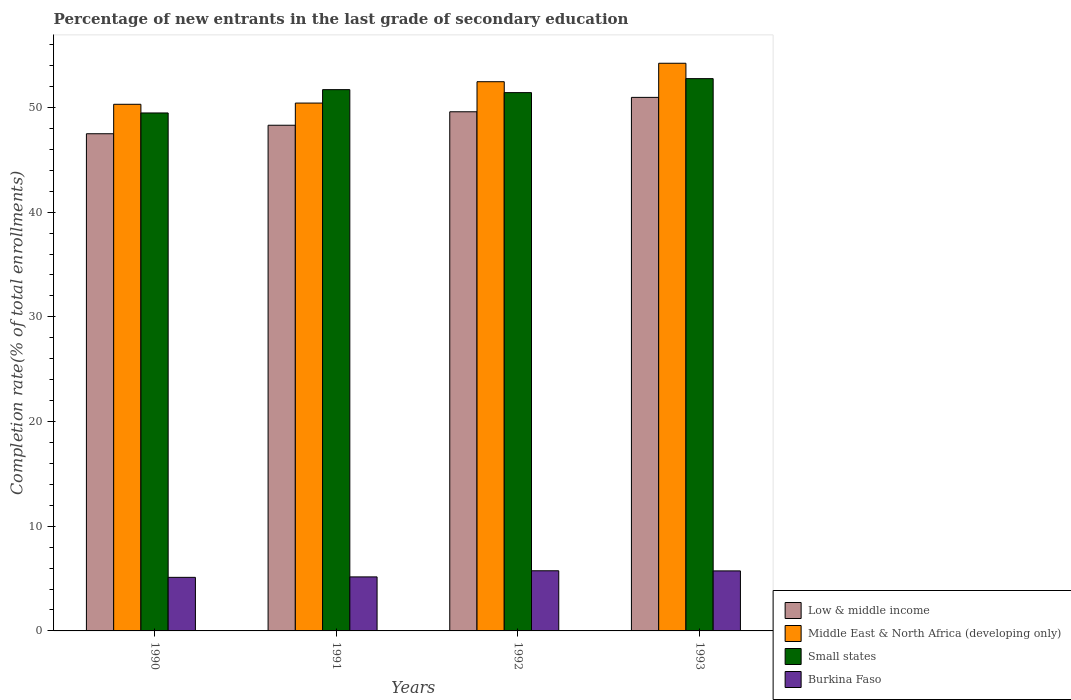How many bars are there on the 2nd tick from the left?
Your answer should be very brief. 4. How many bars are there on the 2nd tick from the right?
Your answer should be very brief. 4. In how many cases, is the number of bars for a given year not equal to the number of legend labels?
Ensure brevity in your answer.  0. What is the percentage of new entrants in Burkina Faso in 1991?
Keep it short and to the point. 5.16. Across all years, what is the maximum percentage of new entrants in Middle East & North Africa (developing only)?
Your response must be concise. 54.22. Across all years, what is the minimum percentage of new entrants in Low & middle income?
Make the answer very short. 47.49. In which year was the percentage of new entrants in Low & middle income maximum?
Offer a very short reply. 1993. In which year was the percentage of new entrants in Small states minimum?
Provide a short and direct response. 1990. What is the total percentage of new entrants in Low & middle income in the graph?
Give a very brief answer. 196.35. What is the difference between the percentage of new entrants in Low & middle income in 1991 and that in 1992?
Your answer should be very brief. -1.29. What is the difference between the percentage of new entrants in Small states in 1991 and the percentage of new entrants in Burkina Faso in 1990?
Offer a very short reply. 46.59. What is the average percentage of new entrants in Middle East & North Africa (developing only) per year?
Your response must be concise. 51.85. In the year 1991, what is the difference between the percentage of new entrants in Low & middle income and percentage of new entrants in Small states?
Your answer should be very brief. -3.4. In how many years, is the percentage of new entrants in Burkina Faso greater than 6 %?
Provide a succinct answer. 0. What is the ratio of the percentage of new entrants in Low & middle income in 1992 to that in 1993?
Give a very brief answer. 0.97. Is the percentage of new entrants in Burkina Faso in 1991 less than that in 1993?
Your answer should be compact. Yes. Is the difference between the percentage of new entrants in Low & middle income in 1990 and 1991 greater than the difference between the percentage of new entrants in Small states in 1990 and 1991?
Make the answer very short. Yes. What is the difference between the highest and the second highest percentage of new entrants in Burkina Faso?
Your answer should be compact. 0.01. What is the difference between the highest and the lowest percentage of new entrants in Small states?
Keep it short and to the point. 3.28. Is the sum of the percentage of new entrants in Small states in 1992 and 1993 greater than the maximum percentage of new entrants in Burkina Faso across all years?
Provide a succinct answer. Yes. Is it the case that in every year, the sum of the percentage of new entrants in Middle East & North Africa (developing only) and percentage of new entrants in Small states is greater than the sum of percentage of new entrants in Burkina Faso and percentage of new entrants in Low & middle income?
Offer a terse response. No. What does the 4th bar from the left in 1992 represents?
Offer a terse response. Burkina Faso. What does the 4th bar from the right in 1993 represents?
Give a very brief answer. Low & middle income. How many legend labels are there?
Offer a very short reply. 4. How are the legend labels stacked?
Provide a short and direct response. Vertical. What is the title of the graph?
Offer a very short reply. Percentage of new entrants in the last grade of secondary education. Does "Belize" appear as one of the legend labels in the graph?
Give a very brief answer. No. What is the label or title of the Y-axis?
Your response must be concise. Completion rate(% of total enrollments). What is the Completion rate(% of total enrollments) of Low & middle income in 1990?
Your answer should be very brief. 47.49. What is the Completion rate(% of total enrollments) in Middle East & North Africa (developing only) in 1990?
Your answer should be very brief. 50.3. What is the Completion rate(% of total enrollments) in Small states in 1990?
Your answer should be very brief. 49.48. What is the Completion rate(% of total enrollments) in Burkina Faso in 1990?
Make the answer very short. 5.12. What is the Completion rate(% of total enrollments) in Low & middle income in 1991?
Offer a very short reply. 48.3. What is the Completion rate(% of total enrollments) of Middle East & North Africa (developing only) in 1991?
Your answer should be compact. 50.42. What is the Completion rate(% of total enrollments) in Small states in 1991?
Your response must be concise. 51.7. What is the Completion rate(% of total enrollments) of Burkina Faso in 1991?
Your answer should be very brief. 5.16. What is the Completion rate(% of total enrollments) in Low & middle income in 1992?
Your answer should be compact. 49.59. What is the Completion rate(% of total enrollments) in Middle East & North Africa (developing only) in 1992?
Offer a very short reply. 52.46. What is the Completion rate(% of total enrollments) of Small states in 1992?
Provide a short and direct response. 51.42. What is the Completion rate(% of total enrollments) in Burkina Faso in 1992?
Provide a short and direct response. 5.75. What is the Completion rate(% of total enrollments) in Low & middle income in 1993?
Your answer should be very brief. 50.96. What is the Completion rate(% of total enrollments) in Middle East & North Africa (developing only) in 1993?
Ensure brevity in your answer.  54.22. What is the Completion rate(% of total enrollments) of Small states in 1993?
Provide a succinct answer. 52.75. What is the Completion rate(% of total enrollments) of Burkina Faso in 1993?
Ensure brevity in your answer.  5.73. Across all years, what is the maximum Completion rate(% of total enrollments) of Low & middle income?
Your answer should be compact. 50.96. Across all years, what is the maximum Completion rate(% of total enrollments) of Middle East & North Africa (developing only)?
Your answer should be very brief. 54.22. Across all years, what is the maximum Completion rate(% of total enrollments) of Small states?
Your answer should be compact. 52.75. Across all years, what is the maximum Completion rate(% of total enrollments) in Burkina Faso?
Offer a very short reply. 5.75. Across all years, what is the minimum Completion rate(% of total enrollments) in Low & middle income?
Offer a very short reply. 47.49. Across all years, what is the minimum Completion rate(% of total enrollments) of Middle East & North Africa (developing only)?
Offer a terse response. 50.3. Across all years, what is the minimum Completion rate(% of total enrollments) in Small states?
Your answer should be very brief. 49.48. Across all years, what is the minimum Completion rate(% of total enrollments) in Burkina Faso?
Your answer should be compact. 5.12. What is the total Completion rate(% of total enrollments) of Low & middle income in the graph?
Provide a succinct answer. 196.35. What is the total Completion rate(% of total enrollments) of Middle East & North Africa (developing only) in the graph?
Make the answer very short. 207.41. What is the total Completion rate(% of total enrollments) in Small states in the graph?
Offer a terse response. 205.35. What is the total Completion rate(% of total enrollments) in Burkina Faso in the graph?
Your response must be concise. 21.76. What is the difference between the Completion rate(% of total enrollments) of Low & middle income in 1990 and that in 1991?
Provide a succinct answer. -0.81. What is the difference between the Completion rate(% of total enrollments) in Middle East & North Africa (developing only) in 1990 and that in 1991?
Keep it short and to the point. -0.12. What is the difference between the Completion rate(% of total enrollments) in Small states in 1990 and that in 1991?
Offer a terse response. -2.23. What is the difference between the Completion rate(% of total enrollments) in Burkina Faso in 1990 and that in 1991?
Your response must be concise. -0.04. What is the difference between the Completion rate(% of total enrollments) in Low & middle income in 1990 and that in 1992?
Offer a terse response. -2.1. What is the difference between the Completion rate(% of total enrollments) of Middle East & North Africa (developing only) in 1990 and that in 1992?
Keep it short and to the point. -2.16. What is the difference between the Completion rate(% of total enrollments) in Small states in 1990 and that in 1992?
Offer a very short reply. -1.94. What is the difference between the Completion rate(% of total enrollments) of Burkina Faso in 1990 and that in 1992?
Ensure brevity in your answer.  -0.63. What is the difference between the Completion rate(% of total enrollments) of Low & middle income in 1990 and that in 1993?
Provide a short and direct response. -3.47. What is the difference between the Completion rate(% of total enrollments) of Middle East & North Africa (developing only) in 1990 and that in 1993?
Keep it short and to the point. -3.92. What is the difference between the Completion rate(% of total enrollments) of Small states in 1990 and that in 1993?
Offer a terse response. -3.28. What is the difference between the Completion rate(% of total enrollments) of Burkina Faso in 1990 and that in 1993?
Offer a terse response. -0.62. What is the difference between the Completion rate(% of total enrollments) in Low & middle income in 1991 and that in 1992?
Your answer should be compact. -1.29. What is the difference between the Completion rate(% of total enrollments) of Middle East & North Africa (developing only) in 1991 and that in 1992?
Your answer should be very brief. -2.04. What is the difference between the Completion rate(% of total enrollments) in Small states in 1991 and that in 1992?
Provide a short and direct response. 0.28. What is the difference between the Completion rate(% of total enrollments) of Burkina Faso in 1991 and that in 1992?
Your answer should be very brief. -0.59. What is the difference between the Completion rate(% of total enrollments) in Low & middle income in 1991 and that in 1993?
Ensure brevity in your answer.  -2.66. What is the difference between the Completion rate(% of total enrollments) of Middle East & North Africa (developing only) in 1991 and that in 1993?
Provide a succinct answer. -3.8. What is the difference between the Completion rate(% of total enrollments) of Small states in 1991 and that in 1993?
Your response must be concise. -1.05. What is the difference between the Completion rate(% of total enrollments) of Burkina Faso in 1991 and that in 1993?
Offer a very short reply. -0.57. What is the difference between the Completion rate(% of total enrollments) of Low & middle income in 1992 and that in 1993?
Your answer should be very brief. -1.37. What is the difference between the Completion rate(% of total enrollments) of Middle East & North Africa (developing only) in 1992 and that in 1993?
Your answer should be compact. -1.76. What is the difference between the Completion rate(% of total enrollments) of Small states in 1992 and that in 1993?
Give a very brief answer. -1.34. What is the difference between the Completion rate(% of total enrollments) in Burkina Faso in 1992 and that in 1993?
Offer a very short reply. 0.01. What is the difference between the Completion rate(% of total enrollments) of Low & middle income in 1990 and the Completion rate(% of total enrollments) of Middle East & North Africa (developing only) in 1991?
Your answer should be compact. -2.93. What is the difference between the Completion rate(% of total enrollments) in Low & middle income in 1990 and the Completion rate(% of total enrollments) in Small states in 1991?
Offer a terse response. -4.21. What is the difference between the Completion rate(% of total enrollments) of Low & middle income in 1990 and the Completion rate(% of total enrollments) of Burkina Faso in 1991?
Provide a succinct answer. 42.33. What is the difference between the Completion rate(% of total enrollments) in Middle East & North Africa (developing only) in 1990 and the Completion rate(% of total enrollments) in Small states in 1991?
Provide a short and direct response. -1.4. What is the difference between the Completion rate(% of total enrollments) in Middle East & North Africa (developing only) in 1990 and the Completion rate(% of total enrollments) in Burkina Faso in 1991?
Provide a short and direct response. 45.14. What is the difference between the Completion rate(% of total enrollments) in Small states in 1990 and the Completion rate(% of total enrollments) in Burkina Faso in 1991?
Keep it short and to the point. 44.32. What is the difference between the Completion rate(% of total enrollments) in Low & middle income in 1990 and the Completion rate(% of total enrollments) in Middle East & North Africa (developing only) in 1992?
Provide a succinct answer. -4.97. What is the difference between the Completion rate(% of total enrollments) of Low & middle income in 1990 and the Completion rate(% of total enrollments) of Small states in 1992?
Your response must be concise. -3.93. What is the difference between the Completion rate(% of total enrollments) in Low & middle income in 1990 and the Completion rate(% of total enrollments) in Burkina Faso in 1992?
Your answer should be compact. 41.75. What is the difference between the Completion rate(% of total enrollments) of Middle East & North Africa (developing only) in 1990 and the Completion rate(% of total enrollments) of Small states in 1992?
Ensure brevity in your answer.  -1.11. What is the difference between the Completion rate(% of total enrollments) in Middle East & North Africa (developing only) in 1990 and the Completion rate(% of total enrollments) in Burkina Faso in 1992?
Your answer should be very brief. 44.56. What is the difference between the Completion rate(% of total enrollments) in Small states in 1990 and the Completion rate(% of total enrollments) in Burkina Faso in 1992?
Keep it short and to the point. 43.73. What is the difference between the Completion rate(% of total enrollments) in Low & middle income in 1990 and the Completion rate(% of total enrollments) in Middle East & North Africa (developing only) in 1993?
Make the answer very short. -6.73. What is the difference between the Completion rate(% of total enrollments) of Low & middle income in 1990 and the Completion rate(% of total enrollments) of Small states in 1993?
Give a very brief answer. -5.26. What is the difference between the Completion rate(% of total enrollments) in Low & middle income in 1990 and the Completion rate(% of total enrollments) in Burkina Faso in 1993?
Provide a succinct answer. 41.76. What is the difference between the Completion rate(% of total enrollments) in Middle East & North Africa (developing only) in 1990 and the Completion rate(% of total enrollments) in Small states in 1993?
Offer a very short reply. -2.45. What is the difference between the Completion rate(% of total enrollments) in Middle East & North Africa (developing only) in 1990 and the Completion rate(% of total enrollments) in Burkina Faso in 1993?
Your response must be concise. 44.57. What is the difference between the Completion rate(% of total enrollments) of Small states in 1990 and the Completion rate(% of total enrollments) of Burkina Faso in 1993?
Offer a terse response. 43.74. What is the difference between the Completion rate(% of total enrollments) in Low & middle income in 1991 and the Completion rate(% of total enrollments) in Middle East & North Africa (developing only) in 1992?
Your answer should be very brief. -4.16. What is the difference between the Completion rate(% of total enrollments) of Low & middle income in 1991 and the Completion rate(% of total enrollments) of Small states in 1992?
Ensure brevity in your answer.  -3.12. What is the difference between the Completion rate(% of total enrollments) in Low & middle income in 1991 and the Completion rate(% of total enrollments) in Burkina Faso in 1992?
Provide a short and direct response. 42.56. What is the difference between the Completion rate(% of total enrollments) in Middle East & North Africa (developing only) in 1991 and the Completion rate(% of total enrollments) in Small states in 1992?
Keep it short and to the point. -1. What is the difference between the Completion rate(% of total enrollments) of Middle East & North Africa (developing only) in 1991 and the Completion rate(% of total enrollments) of Burkina Faso in 1992?
Keep it short and to the point. 44.68. What is the difference between the Completion rate(% of total enrollments) of Small states in 1991 and the Completion rate(% of total enrollments) of Burkina Faso in 1992?
Give a very brief answer. 45.96. What is the difference between the Completion rate(% of total enrollments) of Low & middle income in 1991 and the Completion rate(% of total enrollments) of Middle East & North Africa (developing only) in 1993?
Provide a short and direct response. -5.92. What is the difference between the Completion rate(% of total enrollments) of Low & middle income in 1991 and the Completion rate(% of total enrollments) of Small states in 1993?
Your answer should be very brief. -4.45. What is the difference between the Completion rate(% of total enrollments) in Low & middle income in 1991 and the Completion rate(% of total enrollments) in Burkina Faso in 1993?
Your answer should be very brief. 42.57. What is the difference between the Completion rate(% of total enrollments) of Middle East & North Africa (developing only) in 1991 and the Completion rate(% of total enrollments) of Small states in 1993?
Ensure brevity in your answer.  -2.33. What is the difference between the Completion rate(% of total enrollments) in Middle East & North Africa (developing only) in 1991 and the Completion rate(% of total enrollments) in Burkina Faso in 1993?
Your response must be concise. 44.69. What is the difference between the Completion rate(% of total enrollments) of Small states in 1991 and the Completion rate(% of total enrollments) of Burkina Faso in 1993?
Offer a very short reply. 45.97. What is the difference between the Completion rate(% of total enrollments) in Low & middle income in 1992 and the Completion rate(% of total enrollments) in Middle East & North Africa (developing only) in 1993?
Offer a terse response. -4.63. What is the difference between the Completion rate(% of total enrollments) in Low & middle income in 1992 and the Completion rate(% of total enrollments) in Small states in 1993?
Offer a very short reply. -3.16. What is the difference between the Completion rate(% of total enrollments) in Low & middle income in 1992 and the Completion rate(% of total enrollments) in Burkina Faso in 1993?
Provide a succinct answer. 43.86. What is the difference between the Completion rate(% of total enrollments) of Middle East & North Africa (developing only) in 1992 and the Completion rate(% of total enrollments) of Small states in 1993?
Offer a terse response. -0.29. What is the difference between the Completion rate(% of total enrollments) of Middle East & North Africa (developing only) in 1992 and the Completion rate(% of total enrollments) of Burkina Faso in 1993?
Provide a short and direct response. 46.73. What is the difference between the Completion rate(% of total enrollments) in Small states in 1992 and the Completion rate(% of total enrollments) in Burkina Faso in 1993?
Offer a very short reply. 45.69. What is the average Completion rate(% of total enrollments) in Low & middle income per year?
Make the answer very short. 49.09. What is the average Completion rate(% of total enrollments) of Middle East & North Africa (developing only) per year?
Offer a very short reply. 51.85. What is the average Completion rate(% of total enrollments) in Small states per year?
Ensure brevity in your answer.  51.34. What is the average Completion rate(% of total enrollments) in Burkina Faso per year?
Give a very brief answer. 5.44. In the year 1990, what is the difference between the Completion rate(% of total enrollments) of Low & middle income and Completion rate(% of total enrollments) of Middle East & North Africa (developing only)?
Your answer should be very brief. -2.81. In the year 1990, what is the difference between the Completion rate(% of total enrollments) of Low & middle income and Completion rate(% of total enrollments) of Small states?
Give a very brief answer. -1.99. In the year 1990, what is the difference between the Completion rate(% of total enrollments) of Low & middle income and Completion rate(% of total enrollments) of Burkina Faso?
Keep it short and to the point. 42.37. In the year 1990, what is the difference between the Completion rate(% of total enrollments) in Middle East & North Africa (developing only) and Completion rate(% of total enrollments) in Small states?
Provide a succinct answer. 0.83. In the year 1990, what is the difference between the Completion rate(% of total enrollments) of Middle East & North Africa (developing only) and Completion rate(% of total enrollments) of Burkina Faso?
Your answer should be very brief. 45.19. In the year 1990, what is the difference between the Completion rate(% of total enrollments) in Small states and Completion rate(% of total enrollments) in Burkina Faso?
Ensure brevity in your answer.  44.36. In the year 1991, what is the difference between the Completion rate(% of total enrollments) in Low & middle income and Completion rate(% of total enrollments) in Middle East & North Africa (developing only)?
Offer a very short reply. -2.12. In the year 1991, what is the difference between the Completion rate(% of total enrollments) in Low & middle income and Completion rate(% of total enrollments) in Small states?
Ensure brevity in your answer.  -3.4. In the year 1991, what is the difference between the Completion rate(% of total enrollments) in Low & middle income and Completion rate(% of total enrollments) in Burkina Faso?
Keep it short and to the point. 43.14. In the year 1991, what is the difference between the Completion rate(% of total enrollments) in Middle East & North Africa (developing only) and Completion rate(% of total enrollments) in Small states?
Give a very brief answer. -1.28. In the year 1991, what is the difference between the Completion rate(% of total enrollments) in Middle East & North Africa (developing only) and Completion rate(% of total enrollments) in Burkina Faso?
Ensure brevity in your answer.  45.26. In the year 1991, what is the difference between the Completion rate(% of total enrollments) of Small states and Completion rate(% of total enrollments) of Burkina Faso?
Provide a succinct answer. 46.54. In the year 1992, what is the difference between the Completion rate(% of total enrollments) of Low & middle income and Completion rate(% of total enrollments) of Middle East & North Africa (developing only)?
Your answer should be compact. -2.87. In the year 1992, what is the difference between the Completion rate(% of total enrollments) of Low & middle income and Completion rate(% of total enrollments) of Small states?
Offer a terse response. -1.83. In the year 1992, what is the difference between the Completion rate(% of total enrollments) in Low & middle income and Completion rate(% of total enrollments) in Burkina Faso?
Your answer should be compact. 43.84. In the year 1992, what is the difference between the Completion rate(% of total enrollments) of Middle East & North Africa (developing only) and Completion rate(% of total enrollments) of Small states?
Offer a terse response. 1.04. In the year 1992, what is the difference between the Completion rate(% of total enrollments) of Middle East & North Africa (developing only) and Completion rate(% of total enrollments) of Burkina Faso?
Your answer should be very brief. 46.72. In the year 1992, what is the difference between the Completion rate(% of total enrollments) of Small states and Completion rate(% of total enrollments) of Burkina Faso?
Your answer should be very brief. 45.67. In the year 1993, what is the difference between the Completion rate(% of total enrollments) in Low & middle income and Completion rate(% of total enrollments) in Middle East & North Africa (developing only)?
Your response must be concise. -3.26. In the year 1993, what is the difference between the Completion rate(% of total enrollments) of Low & middle income and Completion rate(% of total enrollments) of Small states?
Your response must be concise. -1.79. In the year 1993, what is the difference between the Completion rate(% of total enrollments) of Low & middle income and Completion rate(% of total enrollments) of Burkina Faso?
Your response must be concise. 45.23. In the year 1993, what is the difference between the Completion rate(% of total enrollments) of Middle East & North Africa (developing only) and Completion rate(% of total enrollments) of Small states?
Provide a succinct answer. 1.47. In the year 1993, what is the difference between the Completion rate(% of total enrollments) of Middle East & North Africa (developing only) and Completion rate(% of total enrollments) of Burkina Faso?
Provide a succinct answer. 48.49. In the year 1993, what is the difference between the Completion rate(% of total enrollments) of Small states and Completion rate(% of total enrollments) of Burkina Faso?
Give a very brief answer. 47.02. What is the ratio of the Completion rate(% of total enrollments) in Low & middle income in 1990 to that in 1991?
Make the answer very short. 0.98. What is the ratio of the Completion rate(% of total enrollments) in Middle East & North Africa (developing only) in 1990 to that in 1991?
Provide a succinct answer. 1. What is the ratio of the Completion rate(% of total enrollments) of Small states in 1990 to that in 1991?
Provide a succinct answer. 0.96. What is the ratio of the Completion rate(% of total enrollments) in Burkina Faso in 1990 to that in 1991?
Offer a very short reply. 0.99. What is the ratio of the Completion rate(% of total enrollments) in Low & middle income in 1990 to that in 1992?
Offer a terse response. 0.96. What is the ratio of the Completion rate(% of total enrollments) in Middle East & North Africa (developing only) in 1990 to that in 1992?
Your answer should be very brief. 0.96. What is the ratio of the Completion rate(% of total enrollments) in Small states in 1990 to that in 1992?
Give a very brief answer. 0.96. What is the ratio of the Completion rate(% of total enrollments) of Burkina Faso in 1990 to that in 1992?
Give a very brief answer. 0.89. What is the ratio of the Completion rate(% of total enrollments) in Low & middle income in 1990 to that in 1993?
Offer a very short reply. 0.93. What is the ratio of the Completion rate(% of total enrollments) of Middle East & North Africa (developing only) in 1990 to that in 1993?
Your answer should be compact. 0.93. What is the ratio of the Completion rate(% of total enrollments) of Small states in 1990 to that in 1993?
Provide a succinct answer. 0.94. What is the ratio of the Completion rate(% of total enrollments) in Burkina Faso in 1990 to that in 1993?
Ensure brevity in your answer.  0.89. What is the ratio of the Completion rate(% of total enrollments) in Low & middle income in 1991 to that in 1992?
Keep it short and to the point. 0.97. What is the ratio of the Completion rate(% of total enrollments) in Middle East & North Africa (developing only) in 1991 to that in 1992?
Your answer should be very brief. 0.96. What is the ratio of the Completion rate(% of total enrollments) of Burkina Faso in 1991 to that in 1992?
Your answer should be compact. 0.9. What is the ratio of the Completion rate(% of total enrollments) of Low & middle income in 1991 to that in 1993?
Offer a very short reply. 0.95. What is the ratio of the Completion rate(% of total enrollments) in Middle East & North Africa (developing only) in 1991 to that in 1993?
Your answer should be compact. 0.93. What is the ratio of the Completion rate(% of total enrollments) of Small states in 1991 to that in 1993?
Give a very brief answer. 0.98. What is the ratio of the Completion rate(% of total enrollments) of Middle East & North Africa (developing only) in 1992 to that in 1993?
Keep it short and to the point. 0.97. What is the ratio of the Completion rate(% of total enrollments) of Small states in 1992 to that in 1993?
Your answer should be very brief. 0.97. What is the difference between the highest and the second highest Completion rate(% of total enrollments) of Low & middle income?
Your response must be concise. 1.37. What is the difference between the highest and the second highest Completion rate(% of total enrollments) in Middle East & North Africa (developing only)?
Your answer should be very brief. 1.76. What is the difference between the highest and the second highest Completion rate(% of total enrollments) of Small states?
Ensure brevity in your answer.  1.05. What is the difference between the highest and the second highest Completion rate(% of total enrollments) in Burkina Faso?
Your answer should be very brief. 0.01. What is the difference between the highest and the lowest Completion rate(% of total enrollments) in Low & middle income?
Your answer should be compact. 3.47. What is the difference between the highest and the lowest Completion rate(% of total enrollments) of Middle East & North Africa (developing only)?
Offer a very short reply. 3.92. What is the difference between the highest and the lowest Completion rate(% of total enrollments) of Small states?
Make the answer very short. 3.28. What is the difference between the highest and the lowest Completion rate(% of total enrollments) in Burkina Faso?
Provide a succinct answer. 0.63. 